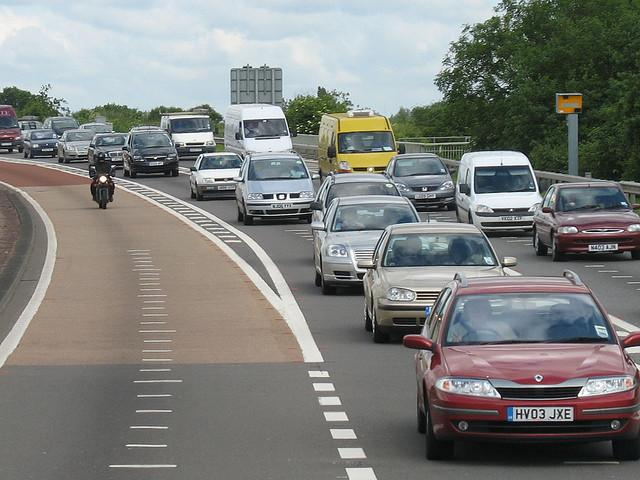Who are the roads for? Please explain your reasoning. drivers. There are no sidewalks, so they are not for pedestrians. vehicles are occupying the roads. 